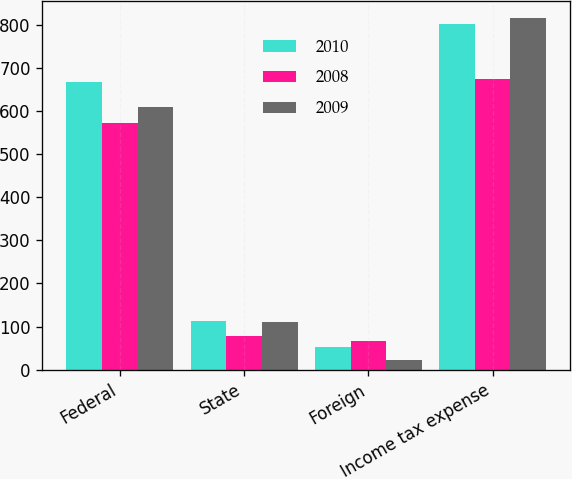Convert chart to OTSL. <chart><loc_0><loc_0><loc_500><loc_500><stacked_bar_chart><ecel><fcel>Federal<fcel>State<fcel>Foreign<fcel>Income tax expense<nl><fcel>2010<fcel>666<fcel>113<fcel>53<fcel>802<nl><fcel>2008<fcel>573<fcel>78<fcel>66<fcel>674<nl><fcel>2009<fcel>609<fcel>110<fcel>22<fcel>815<nl></chart> 